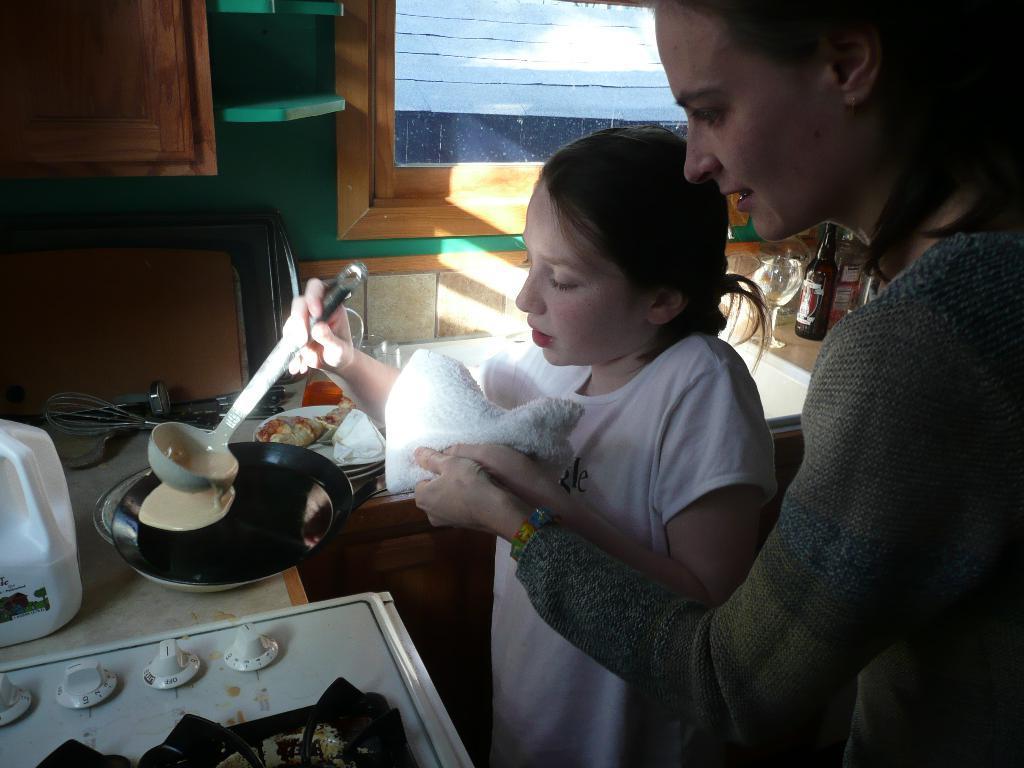In one or two sentences, can you explain what this image depicts? In the picture I can see a woman and a child wearing white color dress is holding a spatula and a cloth is standing. Here we can see the stove, some objects, sink, bottle, glass, wooden cupboards and the glass windows in the background. 